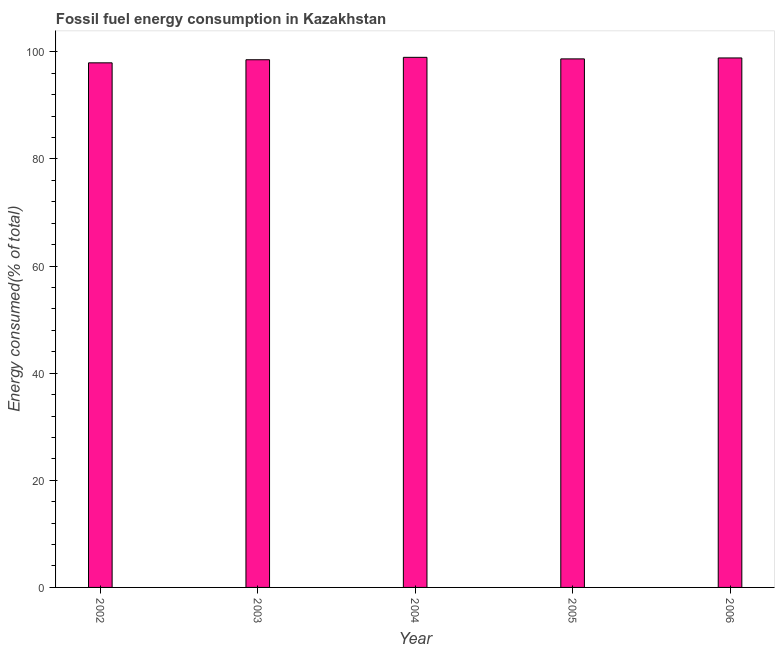Does the graph contain any zero values?
Offer a terse response. No. What is the title of the graph?
Offer a very short reply. Fossil fuel energy consumption in Kazakhstan. What is the label or title of the Y-axis?
Provide a succinct answer. Energy consumed(% of total). What is the fossil fuel energy consumption in 2005?
Your answer should be very brief. 98.67. Across all years, what is the maximum fossil fuel energy consumption?
Your answer should be very brief. 98.96. Across all years, what is the minimum fossil fuel energy consumption?
Your answer should be compact. 97.93. In which year was the fossil fuel energy consumption maximum?
Your answer should be compact. 2004. What is the sum of the fossil fuel energy consumption?
Offer a terse response. 492.93. What is the difference between the fossil fuel energy consumption in 2004 and 2005?
Keep it short and to the point. 0.29. What is the average fossil fuel energy consumption per year?
Ensure brevity in your answer.  98.58. What is the median fossil fuel energy consumption?
Make the answer very short. 98.67. In how many years, is the fossil fuel energy consumption greater than 72 %?
Your response must be concise. 5. Do a majority of the years between 2002 and 2004 (inclusive) have fossil fuel energy consumption greater than 60 %?
Your response must be concise. Yes. Is the fossil fuel energy consumption in 2003 less than that in 2006?
Make the answer very short. Yes. What is the difference between the highest and the second highest fossil fuel energy consumption?
Ensure brevity in your answer.  0.11. Is the sum of the fossil fuel energy consumption in 2004 and 2005 greater than the maximum fossil fuel energy consumption across all years?
Give a very brief answer. Yes. In how many years, is the fossil fuel energy consumption greater than the average fossil fuel energy consumption taken over all years?
Your response must be concise. 3. How many years are there in the graph?
Offer a very short reply. 5. Are the values on the major ticks of Y-axis written in scientific E-notation?
Offer a very short reply. No. What is the Energy consumed(% of total) in 2002?
Ensure brevity in your answer.  97.93. What is the Energy consumed(% of total) of 2003?
Offer a terse response. 98.51. What is the Energy consumed(% of total) of 2004?
Your answer should be compact. 98.96. What is the Energy consumed(% of total) of 2005?
Ensure brevity in your answer.  98.67. What is the Energy consumed(% of total) of 2006?
Provide a succinct answer. 98.85. What is the difference between the Energy consumed(% of total) in 2002 and 2003?
Your answer should be compact. -0.58. What is the difference between the Energy consumed(% of total) in 2002 and 2004?
Keep it short and to the point. -1.03. What is the difference between the Energy consumed(% of total) in 2002 and 2005?
Make the answer very short. -0.74. What is the difference between the Energy consumed(% of total) in 2002 and 2006?
Your answer should be compact. -0.91. What is the difference between the Energy consumed(% of total) in 2003 and 2004?
Your response must be concise. -0.45. What is the difference between the Energy consumed(% of total) in 2003 and 2005?
Make the answer very short. -0.16. What is the difference between the Energy consumed(% of total) in 2003 and 2006?
Provide a short and direct response. -0.34. What is the difference between the Energy consumed(% of total) in 2004 and 2005?
Your response must be concise. 0.29. What is the difference between the Energy consumed(% of total) in 2004 and 2006?
Your answer should be very brief. 0.11. What is the difference between the Energy consumed(% of total) in 2005 and 2006?
Your answer should be very brief. -0.18. What is the ratio of the Energy consumed(% of total) in 2002 to that in 2003?
Provide a succinct answer. 0.99. What is the ratio of the Energy consumed(% of total) in 2002 to that in 2004?
Your answer should be very brief. 0.99. What is the ratio of the Energy consumed(% of total) in 2003 to that in 2004?
Your answer should be very brief. 0.99. What is the ratio of the Energy consumed(% of total) in 2004 to that in 2005?
Offer a very short reply. 1. What is the ratio of the Energy consumed(% of total) in 2004 to that in 2006?
Offer a terse response. 1. What is the ratio of the Energy consumed(% of total) in 2005 to that in 2006?
Your response must be concise. 1. 